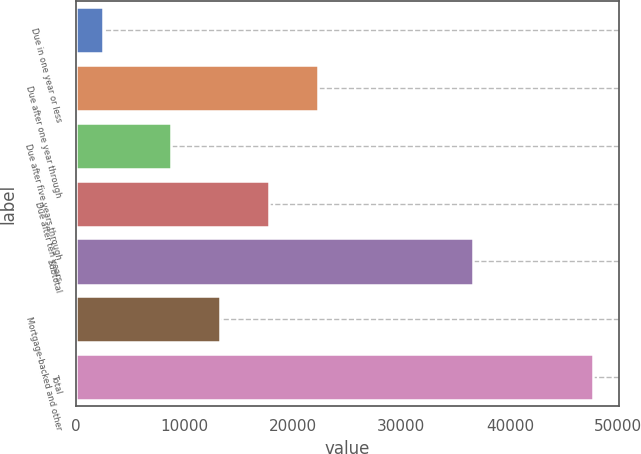Convert chart. <chart><loc_0><loc_0><loc_500><loc_500><bar_chart><fcel>Due in one year or less<fcel>Due after one year through<fcel>Due after five years through<fcel>Due after ten years<fcel>Subtotal<fcel>Mortgage-backed and other<fcel>Total<nl><fcel>2548.1<fcel>22316<fcel>8770.4<fcel>17800.8<fcel>36632<fcel>13285.6<fcel>47700.2<nl></chart> 